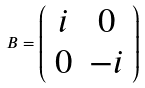Convert formula to latex. <formula><loc_0><loc_0><loc_500><loc_500>B = \left ( \begin{array} { c c } i & 0 \\ 0 & - i \end{array} \right )</formula> 